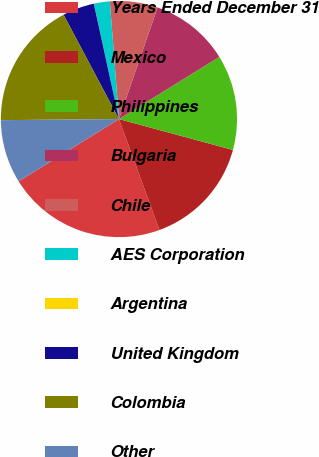<chart> <loc_0><loc_0><loc_500><loc_500><pie_chart><fcel>Years Ended December 31<fcel>Mexico<fcel>Philippines<fcel>Bulgaria<fcel>Chile<fcel>AES Corporation<fcel>Argentina<fcel>United Kingdom<fcel>Colombia<fcel>Other<nl><fcel>21.73%<fcel>15.21%<fcel>13.04%<fcel>10.87%<fcel>6.53%<fcel>2.18%<fcel>0.01%<fcel>4.35%<fcel>17.38%<fcel>8.7%<nl></chart> 